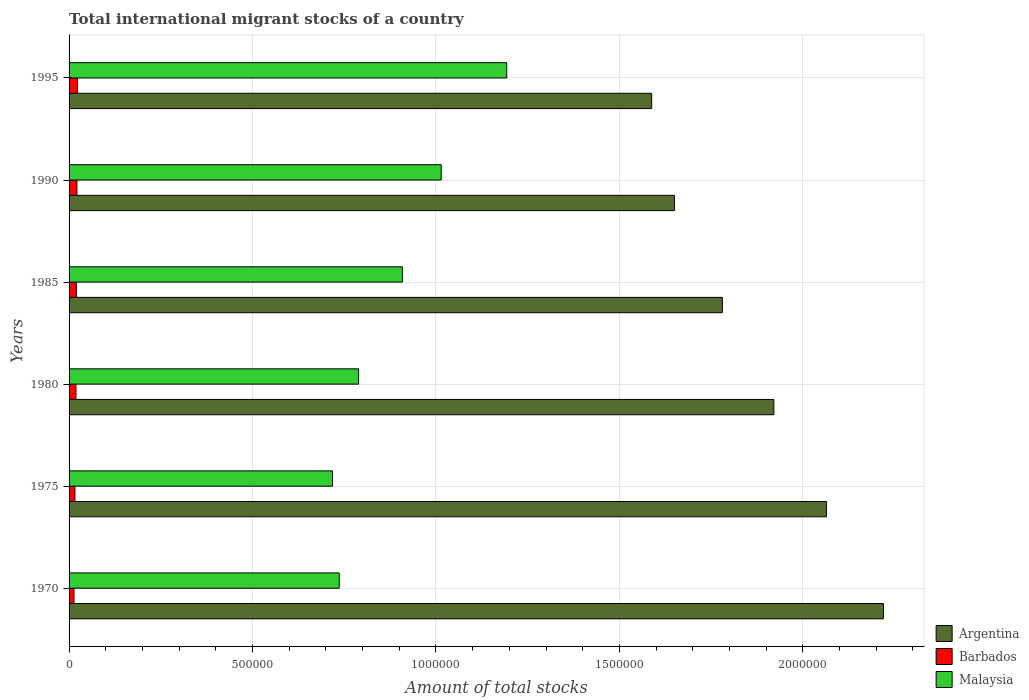How many different coloured bars are there?
Your answer should be compact. 3. Are the number of bars per tick equal to the number of legend labels?
Offer a terse response. Yes. Are the number of bars on each tick of the Y-axis equal?
Offer a terse response. Yes. How many bars are there on the 6th tick from the top?
Your answer should be very brief. 3. What is the label of the 2nd group of bars from the top?
Your answer should be very brief. 1990. What is the amount of total stocks in in Argentina in 1995?
Your response must be concise. 1.59e+06. Across all years, what is the maximum amount of total stocks in in Malaysia?
Offer a very short reply. 1.19e+06. Across all years, what is the minimum amount of total stocks in in Barbados?
Offer a terse response. 1.34e+04. In which year was the amount of total stocks in in Barbados maximum?
Provide a succinct answer. 1995. What is the total amount of total stocks in in Argentina in the graph?
Provide a short and direct response. 1.12e+07. What is the difference between the amount of total stocks in in Malaysia in 1985 and that in 1995?
Ensure brevity in your answer.  -2.84e+05. What is the difference between the amount of total stocks in in Malaysia in 1995 and the amount of total stocks in in Argentina in 1975?
Your response must be concise. -8.71e+05. What is the average amount of total stocks in in Barbados per year?
Give a very brief answer. 1.87e+04. In the year 1980, what is the difference between the amount of total stocks in in Malaysia and amount of total stocks in in Argentina?
Offer a very short reply. -1.13e+06. In how many years, is the amount of total stocks in in Barbados greater than 2100000 ?
Provide a short and direct response. 0. What is the ratio of the amount of total stocks in in Malaysia in 1970 to that in 1995?
Your answer should be very brief. 0.62. What is the difference between the highest and the second highest amount of total stocks in in Malaysia?
Offer a terse response. 1.79e+05. What is the difference between the highest and the lowest amount of total stocks in in Argentina?
Your answer should be very brief. 6.32e+05. What does the 3rd bar from the top in 1970 represents?
Offer a terse response. Argentina. What does the 3rd bar from the bottom in 1995 represents?
Offer a very short reply. Malaysia. Is it the case that in every year, the sum of the amount of total stocks in in Malaysia and amount of total stocks in in Argentina is greater than the amount of total stocks in in Barbados?
Keep it short and to the point. Yes. What is the difference between two consecutive major ticks on the X-axis?
Ensure brevity in your answer.  5.00e+05. How many legend labels are there?
Keep it short and to the point. 3. What is the title of the graph?
Keep it short and to the point. Total international migrant stocks of a country. Does "Slovak Republic" appear as one of the legend labels in the graph?
Your answer should be compact. No. What is the label or title of the X-axis?
Give a very brief answer. Amount of total stocks. What is the label or title of the Y-axis?
Make the answer very short. Years. What is the Amount of total stocks of Argentina in 1970?
Provide a short and direct response. 2.22e+06. What is the Amount of total stocks of Barbados in 1970?
Your response must be concise. 1.34e+04. What is the Amount of total stocks of Malaysia in 1970?
Offer a very short reply. 7.36e+05. What is the Amount of total stocks in Argentina in 1975?
Give a very brief answer. 2.06e+06. What is the Amount of total stocks in Barbados in 1975?
Your answer should be compact. 1.58e+04. What is the Amount of total stocks of Malaysia in 1975?
Your answer should be compact. 7.18e+05. What is the Amount of total stocks in Argentina in 1980?
Your answer should be compact. 1.92e+06. What is the Amount of total stocks of Barbados in 1980?
Provide a short and direct response. 1.87e+04. What is the Amount of total stocks in Malaysia in 1980?
Provide a succinct answer. 7.89e+05. What is the Amount of total stocks in Argentina in 1985?
Your response must be concise. 1.78e+06. What is the Amount of total stocks of Barbados in 1985?
Provide a succinct answer. 2.00e+04. What is the Amount of total stocks of Malaysia in 1985?
Keep it short and to the point. 9.08e+05. What is the Amount of total stocks of Argentina in 1990?
Ensure brevity in your answer.  1.65e+06. What is the Amount of total stocks in Barbados in 1990?
Provide a succinct answer. 2.14e+04. What is the Amount of total stocks in Malaysia in 1990?
Make the answer very short. 1.01e+06. What is the Amount of total stocks in Argentina in 1995?
Give a very brief answer. 1.59e+06. What is the Amount of total stocks in Barbados in 1995?
Offer a very short reply. 2.29e+04. What is the Amount of total stocks of Malaysia in 1995?
Provide a succinct answer. 1.19e+06. Across all years, what is the maximum Amount of total stocks in Argentina?
Your answer should be very brief. 2.22e+06. Across all years, what is the maximum Amount of total stocks of Barbados?
Ensure brevity in your answer.  2.29e+04. Across all years, what is the maximum Amount of total stocks in Malaysia?
Offer a very short reply. 1.19e+06. Across all years, what is the minimum Amount of total stocks in Argentina?
Ensure brevity in your answer.  1.59e+06. Across all years, what is the minimum Amount of total stocks of Barbados?
Offer a very short reply. 1.34e+04. Across all years, what is the minimum Amount of total stocks of Malaysia?
Ensure brevity in your answer.  7.18e+05. What is the total Amount of total stocks of Argentina in the graph?
Provide a succinct answer. 1.12e+07. What is the total Amount of total stocks of Barbados in the graph?
Provide a short and direct response. 1.12e+05. What is the total Amount of total stocks of Malaysia in the graph?
Make the answer very short. 5.36e+06. What is the difference between the Amount of total stocks in Argentina in 1970 and that in 1975?
Provide a succinct answer. 1.55e+05. What is the difference between the Amount of total stocks in Barbados in 1970 and that in 1975?
Offer a very short reply. -2430. What is the difference between the Amount of total stocks in Malaysia in 1970 and that in 1975?
Your answer should be very brief. 1.84e+04. What is the difference between the Amount of total stocks of Argentina in 1970 and that in 1980?
Provide a short and direct response. 2.99e+05. What is the difference between the Amount of total stocks in Barbados in 1970 and that in 1980?
Provide a short and direct response. -5251. What is the difference between the Amount of total stocks of Malaysia in 1970 and that in 1980?
Your answer should be very brief. -5.28e+04. What is the difference between the Amount of total stocks of Argentina in 1970 and that in 1985?
Keep it short and to the point. 4.39e+05. What is the difference between the Amount of total stocks in Barbados in 1970 and that in 1985?
Your answer should be compact. -6565. What is the difference between the Amount of total stocks of Malaysia in 1970 and that in 1985?
Keep it short and to the point. -1.72e+05. What is the difference between the Amount of total stocks of Argentina in 1970 and that in 1990?
Your answer should be compact. 5.69e+05. What is the difference between the Amount of total stocks in Barbados in 1970 and that in 1990?
Provide a succinct answer. -7972. What is the difference between the Amount of total stocks of Malaysia in 1970 and that in 1990?
Ensure brevity in your answer.  -2.78e+05. What is the difference between the Amount of total stocks of Argentina in 1970 and that in 1995?
Ensure brevity in your answer.  6.32e+05. What is the difference between the Amount of total stocks of Barbados in 1970 and that in 1995?
Your response must be concise. -9477. What is the difference between the Amount of total stocks of Malaysia in 1970 and that in 1995?
Your response must be concise. -4.56e+05. What is the difference between the Amount of total stocks of Argentina in 1975 and that in 1980?
Your answer should be compact. 1.43e+05. What is the difference between the Amount of total stocks in Barbados in 1975 and that in 1980?
Your response must be concise. -2821. What is the difference between the Amount of total stocks in Malaysia in 1975 and that in 1980?
Ensure brevity in your answer.  -7.12e+04. What is the difference between the Amount of total stocks in Argentina in 1975 and that in 1985?
Make the answer very short. 2.84e+05. What is the difference between the Amount of total stocks in Barbados in 1975 and that in 1985?
Provide a short and direct response. -4135. What is the difference between the Amount of total stocks in Malaysia in 1975 and that in 1985?
Your answer should be compact. -1.90e+05. What is the difference between the Amount of total stocks of Argentina in 1975 and that in 1990?
Provide a succinct answer. 4.14e+05. What is the difference between the Amount of total stocks in Barbados in 1975 and that in 1990?
Your answer should be compact. -5542. What is the difference between the Amount of total stocks of Malaysia in 1975 and that in 1990?
Your answer should be compact. -2.96e+05. What is the difference between the Amount of total stocks of Argentina in 1975 and that in 1995?
Provide a short and direct response. 4.76e+05. What is the difference between the Amount of total stocks in Barbados in 1975 and that in 1995?
Your answer should be compact. -7047. What is the difference between the Amount of total stocks of Malaysia in 1975 and that in 1995?
Your response must be concise. -4.75e+05. What is the difference between the Amount of total stocks in Argentina in 1980 and that in 1985?
Keep it short and to the point. 1.40e+05. What is the difference between the Amount of total stocks of Barbados in 1980 and that in 1985?
Keep it short and to the point. -1314. What is the difference between the Amount of total stocks of Malaysia in 1980 and that in 1985?
Keep it short and to the point. -1.19e+05. What is the difference between the Amount of total stocks in Argentina in 1980 and that in 1990?
Provide a short and direct response. 2.71e+05. What is the difference between the Amount of total stocks in Barbados in 1980 and that in 1990?
Make the answer very short. -2721. What is the difference between the Amount of total stocks of Malaysia in 1980 and that in 1990?
Offer a terse response. -2.25e+05. What is the difference between the Amount of total stocks of Argentina in 1980 and that in 1995?
Provide a short and direct response. 3.33e+05. What is the difference between the Amount of total stocks of Barbados in 1980 and that in 1995?
Your response must be concise. -4226. What is the difference between the Amount of total stocks of Malaysia in 1980 and that in 1995?
Offer a terse response. -4.04e+05. What is the difference between the Amount of total stocks in Argentina in 1985 and that in 1990?
Make the answer very short. 1.31e+05. What is the difference between the Amount of total stocks in Barbados in 1985 and that in 1990?
Your response must be concise. -1407. What is the difference between the Amount of total stocks of Malaysia in 1985 and that in 1990?
Your response must be concise. -1.06e+05. What is the difference between the Amount of total stocks in Argentina in 1985 and that in 1995?
Keep it short and to the point. 1.93e+05. What is the difference between the Amount of total stocks in Barbados in 1985 and that in 1995?
Make the answer very short. -2912. What is the difference between the Amount of total stocks of Malaysia in 1985 and that in 1995?
Your answer should be compact. -2.84e+05. What is the difference between the Amount of total stocks in Argentina in 1990 and that in 1995?
Offer a terse response. 6.21e+04. What is the difference between the Amount of total stocks in Barbados in 1990 and that in 1995?
Offer a very short reply. -1505. What is the difference between the Amount of total stocks in Malaysia in 1990 and that in 1995?
Keep it short and to the point. -1.79e+05. What is the difference between the Amount of total stocks of Argentina in 1970 and the Amount of total stocks of Barbados in 1975?
Provide a short and direct response. 2.20e+06. What is the difference between the Amount of total stocks in Argentina in 1970 and the Amount of total stocks in Malaysia in 1975?
Offer a very short reply. 1.50e+06. What is the difference between the Amount of total stocks of Barbados in 1970 and the Amount of total stocks of Malaysia in 1975?
Provide a short and direct response. -7.04e+05. What is the difference between the Amount of total stocks of Argentina in 1970 and the Amount of total stocks of Barbados in 1980?
Provide a short and direct response. 2.20e+06. What is the difference between the Amount of total stocks in Argentina in 1970 and the Amount of total stocks in Malaysia in 1980?
Offer a terse response. 1.43e+06. What is the difference between the Amount of total stocks in Barbados in 1970 and the Amount of total stocks in Malaysia in 1980?
Offer a very short reply. -7.76e+05. What is the difference between the Amount of total stocks in Argentina in 1970 and the Amount of total stocks in Barbados in 1985?
Your answer should be very brief. 2.20e+06. What is the difference between the Amount of total stocks of Argentina in 1970 and the Amount of total stocks of Malaysia in 1985?
Ensure brevity in your answer.  1.31e+06. What is the difference between the Amount of total stocks of Barbados in 1970 and the Amount of total stocks of Malaysia in 1985?
Give a very brief answer. -8.95e+05. What is the difference between the Amount of total stocks in Argentina in 1970 and the Amount of total stocks in Barbados in 1990?
Your answer should be compact. 2.20e+06. What is the difference between the Amount of total stocks in Argentina in 1970 and the Amount of total stocks in Malaysia in 1990?
Your answer should be compact. 1.21e+06. What is the difference between the Amount of total stocks in Barbados in 1970 and the Amount of total stocks in Malaysia in 1990?
Keep it short and to the point. -1.00e+06. What is the difference between the Amount of total stocks of Argentina in 1970 and the Amount of total stocks of Barbados in 1995?
Keep it short and to the point. 2.20e+06. What is the difference between the Amount of total stocks of Argentina in 1970 and the Amount of total stocks of Malaysia in 1995?
Make the answer very short. 1.03e+06. What is the difference between the Amount of total stocks of Barbados in 1970 and the Amount of total stocks of Malaysia in 1995?
Give a very brief answer. -1.18e+06. What is the difference between the Amount of total stocks in Argentina in 1975 and the Amount of total stocks in Barbados in 1980?
Make the answer very short. 2.05e+06. What is the difference between the Amount of total stocks in Argentina in 1975 and the Amount of total stocks in Malaysia in 1980?
Provide a short and direct response. 1.28e+06. What is the difference between the Amount of total stocks in Barbados in 1975 and the Amount of total stocks in Malaysia in 1980?
Offer a terse response. -7.73e+05. What is the difference between the Amount of total stocks of Argentina in 1975 and the Amount of total stocks of Barbados in 1985?
Offer a very short reply. 2.04e+06. What is the difference between the Amount of total stocks of Argentina in 1975 and the Amount of total stocks of Malaysia in 1985?
Your response must be concise. 1.16e+06. What is the difference between the Amount of total stocks of Barbados in 1975 and the Amount of total stocks of Malaysia in 1985?
Provide a short and direct response. -8.93e+05. What is the difference between the Amount of total stocks in Argentina in 1975 and the Amount of total stocks in Barbados in 1990?
Provide a short and direct response. 2.04e+06. What is the difference between the Amount of total stocks of Argentina in 1975 and the Amount of total stocks of Malaysia in 1990?
Your answer should be compact. 1.05e+06. What is the difference between the Amount of total stocks of Barbados in 1975 and the Amount of total stocks of Malaysia in 1990?
Provide a short and direct response. -9.98e+05. What is the difference between the Amount of total stocks of Argentina in 1975 and the Amount of total stocks of Barbados in 1995?
Keep it short and to the point. 2.04e+06. What is the difference between the Amount of total stocks of Argentina in 1975 and the Amount of total stocks of Malaysia in 1995?
Your answer should be very brief. 8.71e+05. What is the difference between the Amount of total stocks in Barbados in 1975 and the Amount of total stocks in Malaysia in 1995?
Provide a succinct answer. -1.18e+06. What is the difference between the Amount of total stocks in Argentina in 1980 and the Amount of total stocks in Barbados in 1985?
Offer a very short reply. 1.90e+06. What is the difference between the Amount of total stocks in Argentina in 1980 and the Amount of total stocks in Malaysia in 1985?
Offer a very short reply. 1.01e+06. What is the difference between the Amount of total stocks in Barbados in 1980 and the Amount of total stocks in Malaysia in 1985?
Your answer should be compact. -8.90e+05. What is the difference between the Amount of total stocks of Argentina in 1980 and the Amount of total stocks of Barbados in 1990?
Ensure brevity in your answer.  1.90e+06. What is the difference between the Amount of total stocks in Argentina in 1980 and the Amount of total stocks in Malaysia in 1990?
Offer a terse response. 9.07e+05. What is the difference between the Amount of total stocks in Barbados in 1980 and the Amount of total stocks in Malaysia in 1990?
Your answer should be very brief. -9.95e+05. What is the difference between the Amount of total stocks of Argentina in 1980 and the Amount of total stocks of Barbados in 1995?
Your response must be concise. 1.90e+06. What is the difference between the Amount of total stocks of Argentina in 1980 and the Amount of total stocks of Malaysia in 1995?
Your answer should be compact. 7.28e+05. What is the difference between the Amount of total stocks of Barbados in 1980 and the Amount of total stocks of Malaysia in 1995?
Provide a short and direct response. -1.17e+06. What is the difference between the Amount of total stocks of Argentina in 1985 and the Amount of total stocks of Barbados in 1990?
Keep it short and to the point. 1.76e+06. What is the difference between the Amount of total stocks of Argentina in 1985 and the Amount of total stocks of Malaysia in 1990?
Your answer should be compact. 7.66e+05. What is the difference between the Amount of total stocks in Barbados in 1985 and the Amount of total stocks in Malaysia in 1990?
Offer a very short reply. -9.94e+05. What is the difference between the Amount of total stocks in Argentina in 1985 and the Amount of total stocks in Barbados in 1995?
Your answer should be very brief. 1.76e+06. What is the difference between the Amount of total stocks of Argentina in 1985 and the Amount of total stocks of Malaysia in 1995?
Offer a very short reply. 5.88e+05. What is the difference between the Amount of total stocks in Barbados in 1985 and the Amount of total stocks in Malaysia in 1995?
Your answer should be compact. -1.17e+06. What is the difference between the Amount of total stocks of Argentina in 1990 and the Amount of total stocks of Barbados in 1995?
Offer a terse response. 1.63e+06. What is the difference between the Amount of total stocks in Argentina in 1990 and the Amount of total stocks in Malaysia in 1995?
Offer a very short reply. 4.57e+05. What is the difference between the Amount of total stocks in Barbados in 1990 and the Amount of total stocks in Malaysia in 1995?
Keep it short and to the point. -1.17e+06. What is the average Amount of total stocks in Argentina per year?
Your answer should be very brief. 1.87e+06. What is the average Amount of total stocks of Barbados per year?
Make the answer very short. 1.87e+04. What is the average Amount of total stocks in Malaysia per year?
Your answer should be very brief. 8.93e+05. In the year 1970, what is the difference between the Amount of total stocks of Argentina and Amount of total stocks of Barbados?
Your answer should be very brief. 2.21e+06. In the year 1970, what is the difference between the Amount of total stocks in Argentina and Amount of total stocks in Malaysia?
Ensure brevity in your answer.  1.48e+06. In the year 1970, what is the difference between the Amount of total stocks in Barbados and Amount of total stocks in Malaysia?
Provide a short and direct response. -7.23e+05. In the year 1975, what is the difference between the Amount of total stocks in Argentina and Amount of total stocks in Barbados?
Provide a succinct answer. 2.05e+06. In the year 1975, what is the difference between the Amount of total stocks of Argentina and Amount of total stocks of Malaysia?
Provide a succinct answer. 1.35e+06. In the year 1975, what is the difference between the Amount of total stocks in Barbados and Amount of total stocks in Malaysia?
Provide a short and direct response. -7.02e+05. In the year 1980, what is the difference between the Amount of total stocks of Argentina and Amount of total stocks of Barbados?
Offer a terse response. 1.90e+06. In the year 1980, what is the difference between the Amount of total stocks of Argentina and Amount of total stocks of Malaysia?
Keep it short and to the point. 1.13e+06. In the year 1980, what is the difference between the Amount of total stocks in Barbados and Amount of total stocks in Malaysia?
Offer a terse response. -7.70e+05. In the year 1985, what is the difference between the Amount of total stocks in Argentina and Amount of total stocks in Barbados?
Provide a short and direct response. 1.76e+06. In the year 1985, what is the difference between the Amount of total stocks in Argentina and Amount of total stocks in Malaysia?
Your response must be concise. 8.72e+05. In the year 1985, what is the difference between the Amount of total stocks in Barbados and Amount of total stocks in Malaysia?
Give a very brief answer. -8.88e+05. In the year 1990, what is the difference between the Amount of total stocks of Argentina and Amount of total stocks of Barbados?
Your answer should be compact. 1.63e+06. In the year 1990, what is the difference between the Amount of total stocks of Argentina and Amount of total stocks of Malaysia?
Offer a very short reply. 6.36e+05. In the year 1990, what is the difference between the Amount of total stocks of Barbados and Amount of total stocks of Malaysia?
Make the answer very short. -9.93e+05. In the year 1995, what is the difference between the Amount of total stocks in Argentina and Amount of total stocks in Barbados?
Keep it short and to the point. 1.56e+06. In the year 1995, what is the difference between the Amount of total stocks of Argentina and Amount of total stocks of Malaysia?
Offer a very short reply. 3.95e+05. In the year 1995, what is the difference between the Amount of total stocks in Barbados and Amount of total stocks in Malaysia?
Provide a succinct answer. -1.17e+06. What is the ratio of the Amount of total stocks of Argentina in 1970 to that in 1975?
Provide a short and direct response. 1.08. What is the ratio of the Amount of total stocks in Barbados in 1970 to that in 1975?
Offer a terse response. 0.85. What is the ratio of the Amount of total stocks in Malaysia in 1970 to that in 1975?
Your answer should be compact. 1.03. What is the ratio of the Amount of total stocks of Argentina in 1970 to that in 1980?
Offer a terse response. 1.16. What is the ratio of the Amount of total stocks in Barbados in 1970 to that in 1980?
Your response must be concise. 0.72. What is the ratio of the Amount of total stocks of Malaysia in 1970 to that in 1980?
Offer a very short reply. 0.93. What is the ratio of the Amount of total stocks in Argentina in 1970 to that in 1985?
Your answer should be very brief. 1.25. What is the ratio of the Amount of total stocks in Barbados in 1970 to that in 1985?
Offer a very short reply. 0.67. What is the ratio of the Amount of total stocks in Malaysia in 1970 to that in 1985?
Your answer should be very brief. 0.81. What is the ratio of the Amount of total stocks in Argentina in 1970 to that in 1990?
Keep it short and to the point. 1.35. What is the ratio of the Amount of total stocks in Barbados in 1970 to that in 1990?
Your response must be concise. 0.63. What is the ratio of the Amount of total stocks of Malaysia in 1970 to that in 1990?
Keep it short and to the point. 0.73. What is the ratio of the Amount of total stocks of Argentina in 1970 to that in 1995?
Give a very brief answer. 1.4. What is the ratio of the Amount of total stocks in Barbados in 1970 to that in 1995?
Offer a very short reply. 0.59. What is the ratio of the Amount of total stocks of Malaysia in 1970 to that in 1995?
Your answer should be compact. 0.62. What is the ratio of the Amount of total stocks of Argentina in 1975 to that in 1980?
Your answer should be compact. 1.07. What is the ratio of the Amount of total stocks of Barbados in 1975 to that in 1980?
Provide a succinct answer. 0.85. What is the ratio of the Amount of total stocks of Malaysia in 1975 to that in 1980?
Give a very brief answer. 0.91. What is the ratio of the Amount of total stocks in Argentina in 1975 to that in 1985?
Offer a very short reply. 1.16. What is the ratio of the Amount of total stocks of Barbados in 1975 to that in 1985?
Provide a succinct answer. 0.79. What is the ratio of the Amount of total stocks of Malaysia in 1975 to that in 1985?
Offer a terse response. 0.79. What is the ratio of the Amount of total stocks in Argentina in 1975 to that in 1990?
Keep it short and to the point. 1.25. What is the ratio of the Amount of total stocks of Barbados in 1975 to that in 1990?
Offer a very short reply. 0.74. What is the ratio of the Amount of total stocks in Malaysia in 1975 to that in 1990?
Make the answer very short. 0.71. What is the ratio of the Amount of total stocks in Barbados in 1975 to that in 1995?
Provide a short and direct response. 0.69. What is the ratio of the Amount of total stocks of Malaysia in 1975 to that in 1995?
Your answer should be very brief. 0.6. What is the ratio of the Amount of total stocks in Argentina in 1980 to that in 1985?
Make the answer very short. 1.08. What is the ratio of the Amount of total stocks in Barbados in 1980 to that in 1985?
Your answer should be compact. 0.93. What is the ratio of the Amount of total stocks in Malaysia in 1980 to that in 1985?
Provide a short and direct response. 0.87. What is the ratio of the Amount of total stocks in Argentina in 1980 to that in 1990?
Make the answer very short. 1.16. What is the ratio of the Amount of total stocks in Barbados in 1980 to that in 1990?
Your answer should be compact. 0.87. What is the ratio of the Amount of total stocks of Malaysia in 1980 to that in 1990?
Ensure brevity in your answer.  0.78. What is the ratio of the Amount of total stocks in Argentina in 1980 to that in 1995?
Your answer should be very brief. 1.21. What is the ratio of the Amount of total stocks in Barbados in 1980 to that in 1995?
Offer a very short reply. 0.82. What is the ratio of the Amount of total stocks in Malaysia in 1980 to that in 1995?
Offer a very short reply. 0.66. What is the ratio of the Amount of total stocks in Argentina in 1985 to that in 1990?
Give a very brief answer. 1.08. What is the ratio of the Amount of total stocks in Barbados in 1985 to that in 1990?
Give a very brief answer. 0.93. What is the ratio of the Amount of total stocks in Malaysia in 1985 to that in 1990?
Give a very brief answer. 0.9. What is the ratio of the Amount of total stocks of Argentina in 1985 to that in 1995?
Offer a terse response. 1.12. What is the ratio of the Amount of total stocks in Barbados in 1985 to that in 1995?
Keep it short and to the point. 0.87. What is the ratio of the Amount of total stocks of Malaysia in 1985 to that in 1995?
Provide a short and direct response. 0.76. What is the ratio of the Amount of total stocks in Argentina in 1990 to that in 1995?
Ensure brevity in your answer.  1.04. What is the ratio of the Amount of total stocks of Barbados in 1990 to that in 1995?
Keep it short and to the point. 0.93. What is the ratio of the Amount of total stocks of Malaysia in 1990 to that in 1995?
Provide a succinct answer. 0.85. What is the difference between the highest and the second highest Amount of total stocks in Argentina?
Offer a very short reply. 1.55e+05. What is the difference between the highest and the second highest Amount of total stocks in Barbados?
Provide a succinct answer. 1505. What is the difference between the highest and the second highest Amount of total stocks of Malaysia?
Offer a terse response. 1.79e+05. What is the difference between the highest and the lowest Amount of total stocks in Argentina?
Your answer should be compact. 6.32e+05. What is the difference between the highest and the lowest Amount of total stocks in Barbados?
Ensure brevity in your answer.  9477. What is the difference between the highest and the lowest Amount of total stocks of Malaysia?
Your answer should be very brief. 4.75e+05. 